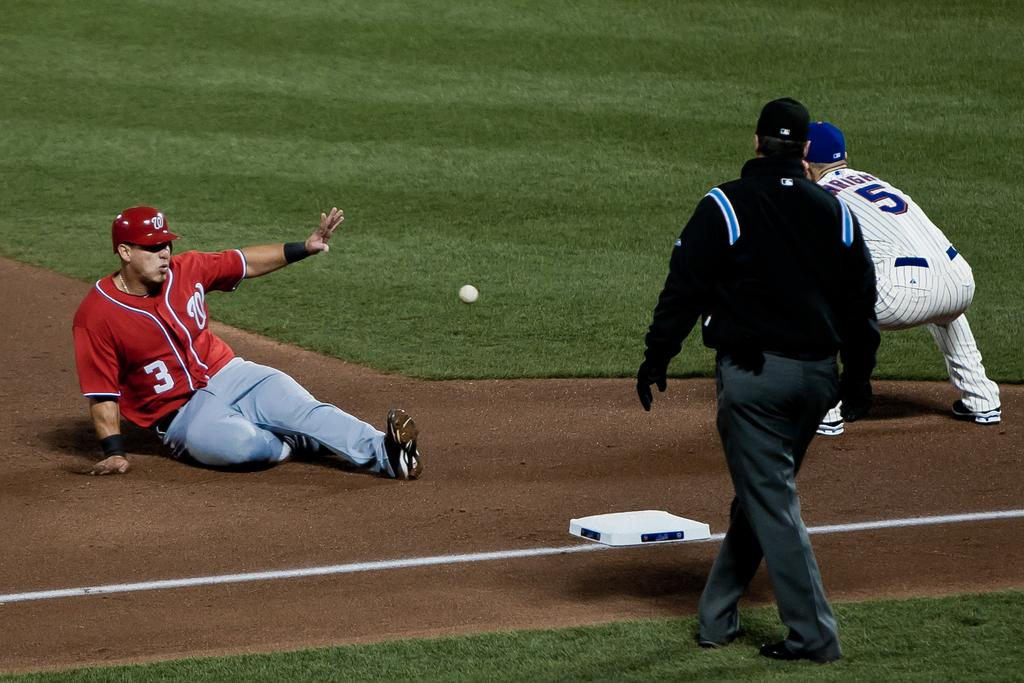<image>
Present a compact description of the photo's key features. Baseball player wearing number 3 sliding to base. 